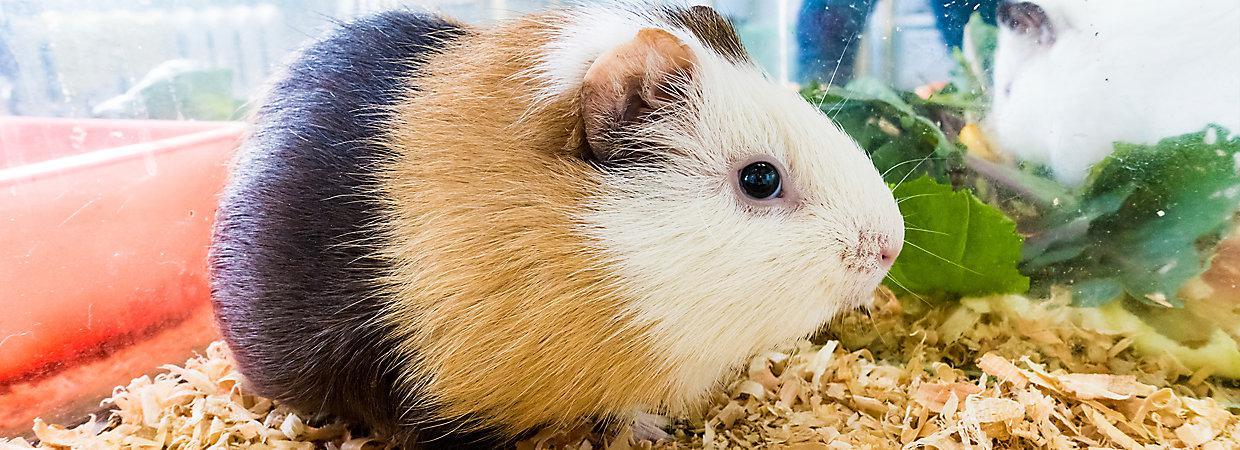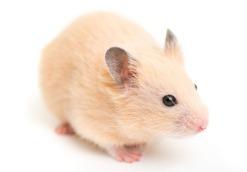The first image is the image on the left, the second image is the image on the right. For the images shown, is this caption "One hamster is tri-colored." true? Answer yes or no. Yes. 